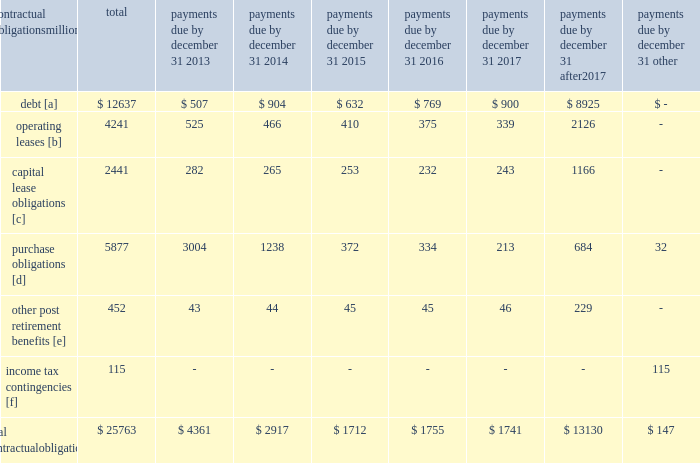Credit rating fall below investment grade , the value of the outstanding undivided interest held by investors would be reduced , and , in certain cases , the investors would have the right to discontinue the facility .
The railroad collected approximately $ 20.1 billion and $ 18.8 billion of receivables during the years ended december 31 , 2012 and 2011 , respectively .
Upri used certain of these proceeds to purchase new receivables under the facility .
The costs of the receivables securitization facility include interest , which will vary based on prevailing commercial paper rates , program fees paid to banks , commercial paper issuing costs , and fees for unused commitment availability .
The costs of the receivables securitization facility are included in interest expense and were $ 3 million , $ 4 million and $ 6 million for 2012 , 2011 and 2010 , respectively .
The investors have no recourse to the railroad 2019s other assets , except for customary warranty and indemnity claims .
Creditors of the railroad do not have recourse to the assets of upri .
In july 2012 , the receivables securitization facility was renewed for an additional 364-day period at comparable terms and conditions .
Subsequent event 2013 on january 2 , 2013 , we transferred an additional $ 300 million in undivided interest to investors under the receivables securitization facility , increasing the value of the outstanding undivided interest held by investors from $ 100 million to $ 400 million .
Contractual obligations and commercial commitments as described in the notes to the consolidated financial statements and as referenced in the tables below , we have contractual obligations and commercial commitments that may affect our financial condition .
Based on our assessment of the underlying provisions and circumstances of our contractual obligations and commercial commitments , including material sources of off-balance sheet and structured finance arrangements , other than the risks that we and other similarly situated companies face with respect to the condition of the capital markets ( as described in item 1a of part ii of this report ) , there is no known trend , demand , commitment , event , or uncertainty that is reasonably likely to occur that would have a material adverse effect on our consolidated results of operations , financial condition , or liquidity .
In addition , our commercial obligations , financings , and commitments are customary transactions that are similar to those of other comparable corporations , particularly within the transportation industry .
The tables identify material obligations and commitments as of december 31 , 2012 : payments due by december 31 , contractual obligations after millions total 2013 2014 2015 2016 2017 2017 other .
[a] excludes capital lease obligations of $ 1848 million and unamortized discount of $ ( 365 ) million .
Includes an interest component of $ 5123 million .
[b] includes leases for locomotives , freight cars , other equipment , and real estate .
[c] represents total obligations , including interest component of $ 593 million .
[d] purchase obligations include locomotive maintenance contracts ; purchase commitments for fuel purchases , locomotives , ties , ballast , and rail ; and agreements to purchase other goods and services .
For amounts where we cannot reasonably estimate the year of settlement , they are reflected in the other column .
[e] includes estimated other post retirement , medical , and life insurance payments , payments made under the unfunded pension plan for the next ten years .
[f] future cash flows for income tax contingencies reflect the recorded liabilities and assets for unrecognized tax benefits , including interest and penalties , as of december 31 , 2012 .
For amounts where the year of settlement is uncertain , they are reflected in the other column. .
What percentage of total material obligations and commitments as of december 31 , 2012 are operating leases? 
Computations: (4241 / 25763)
Answer: 0.16462. 